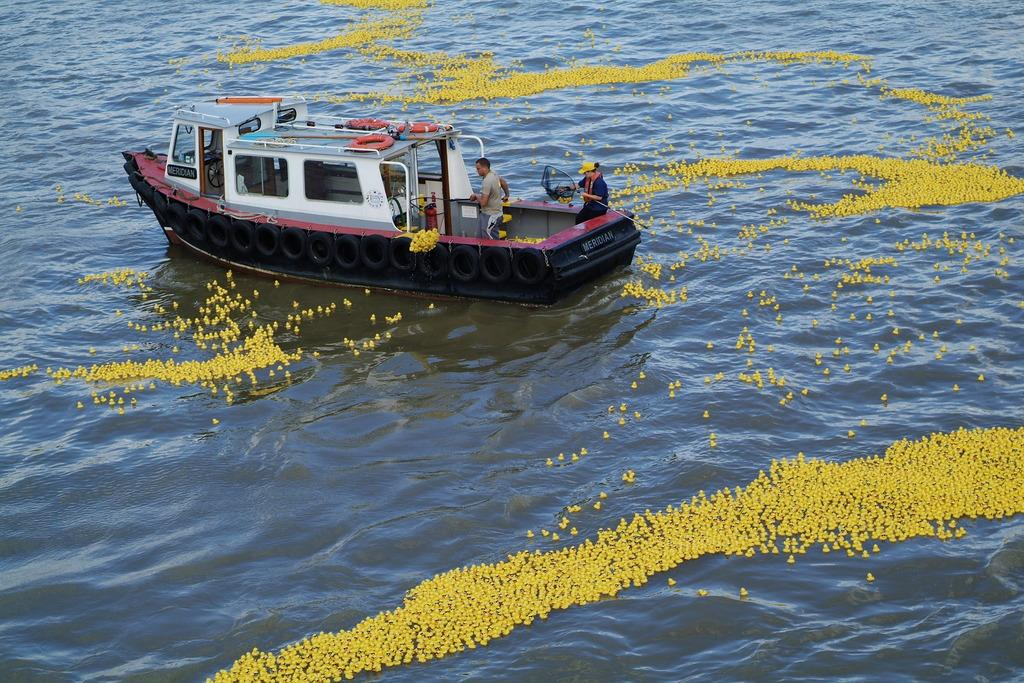How many people are in the image? There are two people in the image. What are the two people doing in the image? The two people are on a boat. What is the main object in the image? There is a boat in the image. What can be seen above the water in the image? There are yellow objects above the water in the image. How many eggs can be seen in the image? There are no eggs present in the image. 